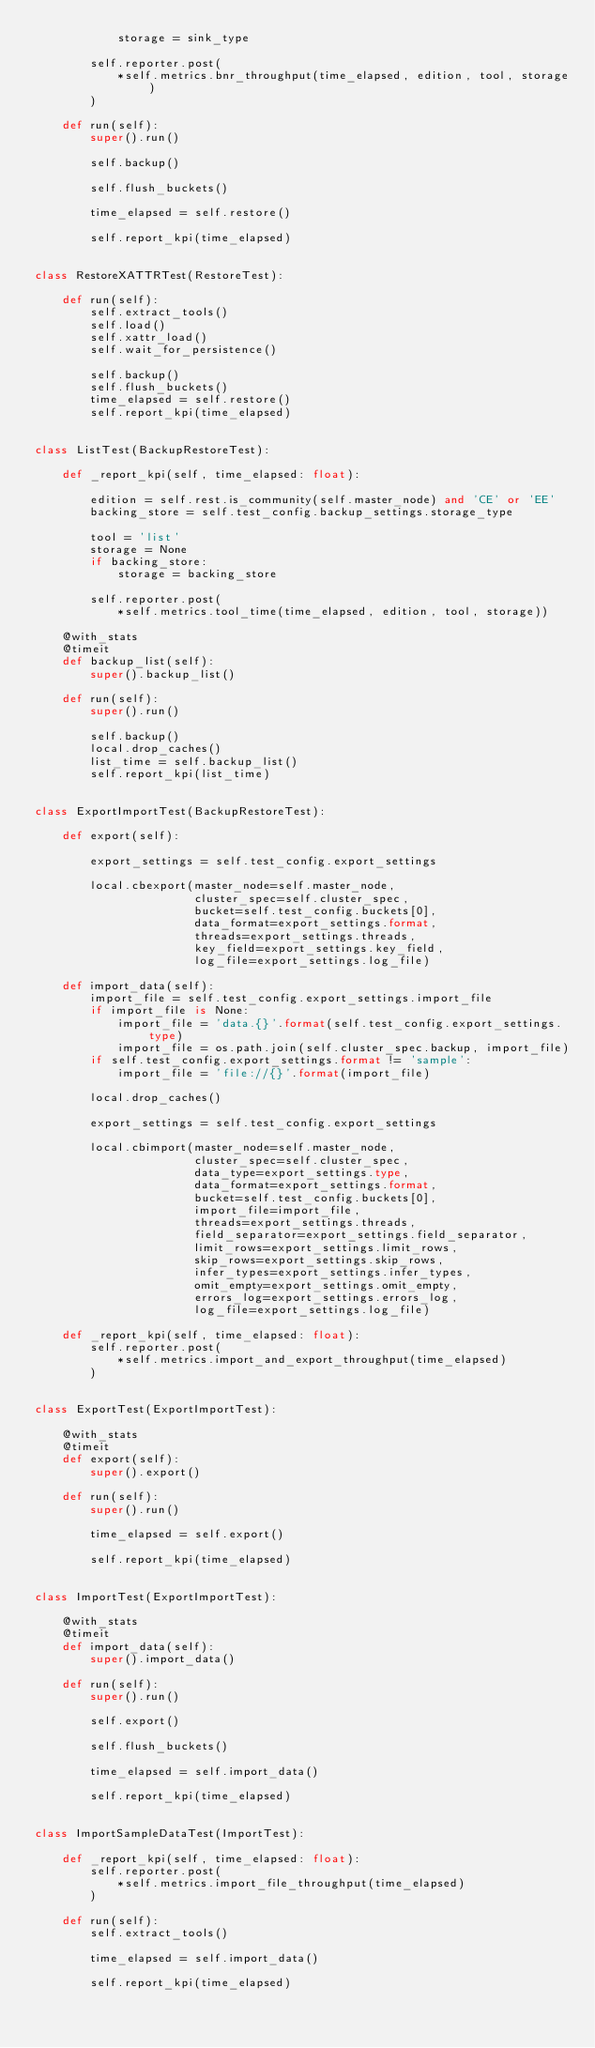Convert code to text. <code><loc_0><loc_0><loc_500><loc_500><_Python_>            storage = sink_type

        self.reporter.post(
            *self.metrics.bnr_throughput(time_elapsed, edition, tool, storage)
        )

    def run(self):
        super().run()

        self.backup()

        self.flush_buckets()

        time_elapsed = self.restore()

        self.report_kpi(time_elapsed)


class RestoreXATTRTest(RestoreTest):

    def run(self):
        self.extract_tools()
        self.load()
        self.xattr_load()
        self.wait_for_persistence()

        self.backup()
        self.flush_buckets()
        time_elapsed = self.restore()
        self.report_kpi(time_elapsed)


class ListTest(BackupRestoreTest):

    def _report_kpi(self, time_elapsed: float):

        edition = self.rest.is_community(self.master_node) and 'CE' or 'EE'
        backing_store = self.test_config.backup_settings.storage_type

        tool = 'list'
        storage = None
        if backing_store:
            storage = backing_store

        self.reporter.post(
            *self.metrics.tool_time(time_elapsed, edition, tool, storage))

    @with_stats
    @timeit
    def backup_list(self):
        super().backup_list()

    def run(self):
        super().run()

        self.backup()
        local.drop_caches()
        list_time = self.backup_list()
        self.report_kpi(list_time)


class ExportImportTest(BackupRestoreTest):

    def export(self):

        export_settings = self.test_config.export_settings

        local.cbexport(master_node=self.master_node,
                       cluster_spec=self.cluster_spec,
                       bucket=self.test_config.buckets[0],
                       data_format=export_settings.format,
                       threads=export_settings.threads,
                       key_field=export_settings.key_field,
                       log_file=export_settings.log_file)

    def import_data(self):
        import_file = self.test_config.export_settings.import_file
        if import_file is None:
            import_file = 'data.{}'.format(self.test_config.export_settings.type)
            import_file = os.path.join(self.cluster_spec.backup, import_file)
        if self.test_config.export_settings.format != 'sample':
            import_file = 'file://{}'.format(import_file)

        local.drop_caches()

        export_settings = self.test_config.export_settings

        local.cbimport(master_node=self.master_node,
                       cluster_spec=self.cluster_spec,
                       data_type=export_settings.type,
                       data_format=export_settings.format,
                       bucket=self.test_config.buckets[0],
                       import_file=import_file,
                       threads=export_settings.threads,
                       field_separator=export_settings.field_separator,
                       limit_rows=export_settings.limit_rows,
                       skip_rows=export_settings.skip_rows,
                       infer_types=export_settings.infer_types,
                       omit_empty=export_settings.omit_empty,
                       errors_log=export_settings.errors_log,
                       log_file=export_settings.log_file)

    def _report_kpi(self, time_elapsed: float):
        self.reporter.post(
            *self.metrics.import_and_export_throughput(time_elapsed)
        )


class ExportTest(ExportImportTest):

    @with_stats
    @timeit
    def export(self):
        super().export()

    def run(self):
        super().run()

        time_elapsed = self.export()

        self.report_kpi(time_elapsed)


class ImportTest(ExportImportTest):

    @with_stats
    @timeit
    def import_data(self):
        super().import_data()

    def run(self):
        super().run()

        self.export()

        self.flush_buckets()

        time_elapsed = self.import_data()

        self.report_kpi(time_elapsed)


class ImportSampleDataTest(ImportTest):

    def _report_kpi(self, time_elapsed: float):
        self.reporter.post(
            *self.metrics.import_file_throughput(time_elapsed)
        )

    def run(self):
        self.extract_tools()

        time_elapsed = self.import_data()

        self.report_kpi(time_elapsed)
</code> 